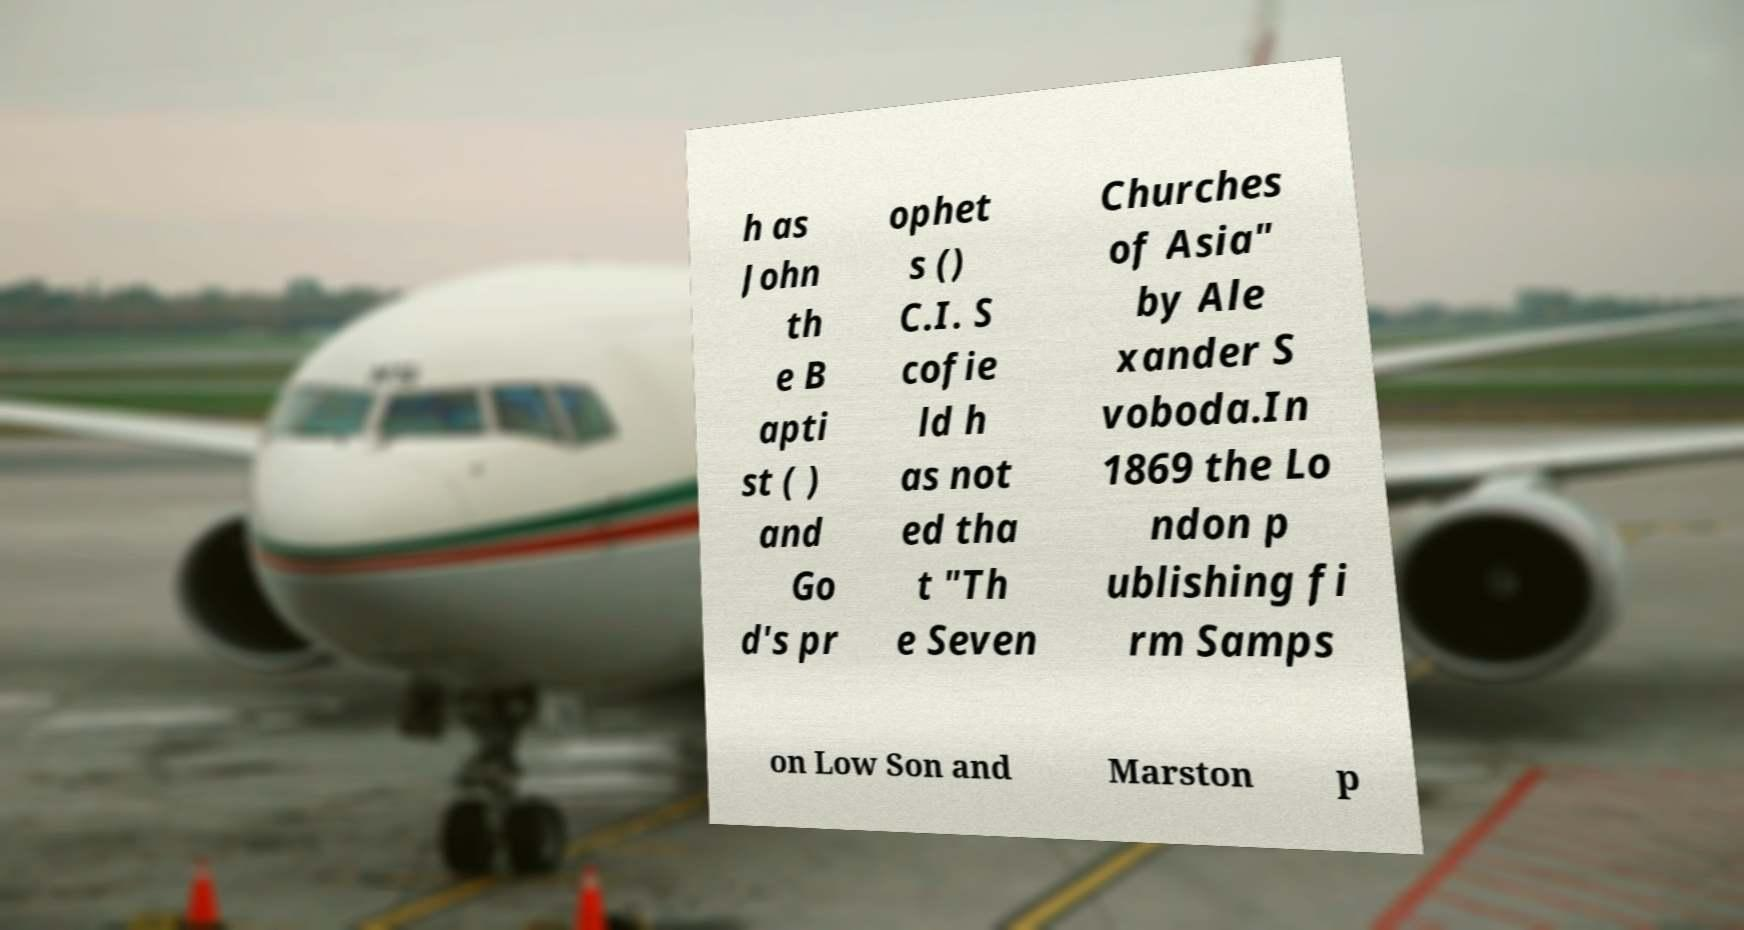There's text embedded in this image that I need extracted. Can you transcribe it verbatim? h as John th e B apti st ( ) and Go d's pr ophet s () C.I. S cofie ld h as not ed tha t "Th e Seven Churches of Asia" by Ale xander S voboda.In 1869 the Lo ndon p ublishing fi rm Samps on Low Son and Marston p 